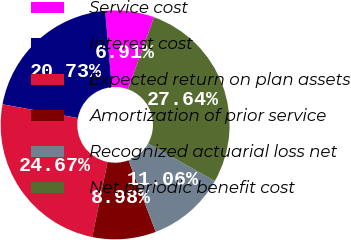Convert chart to OTSL. <chart><loc_0><loc_0><loc_500><loc_500><pie_chart><fcel>Service cost<fcel>Interest cost<fcel>Expected return on plan assets<fcel>Amortization of prior service<fcel>Recognized actuarial loss net<fcel>Net periodic benefit cost<nl><fcel>6.91%<fcel>20.73%<fcel>24.67%<fcel>8.98%<fcel>11.06%<fcel>27.64%<nl></chart> 